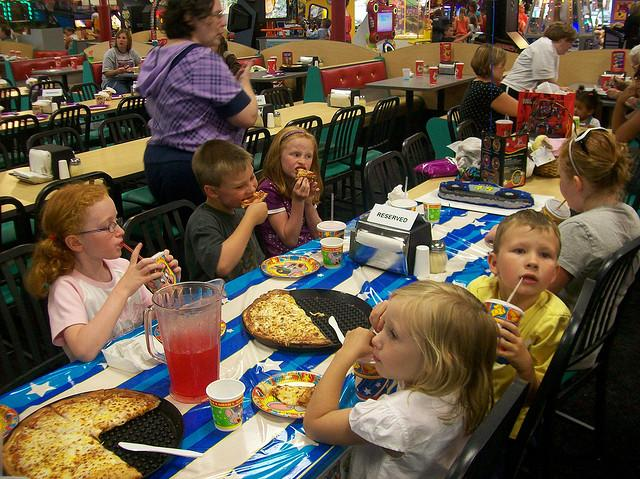What is a likely occasion for all the kids getting together?

Choices:
A) funeral
B) school
C) church
D) birthday party birthday party 